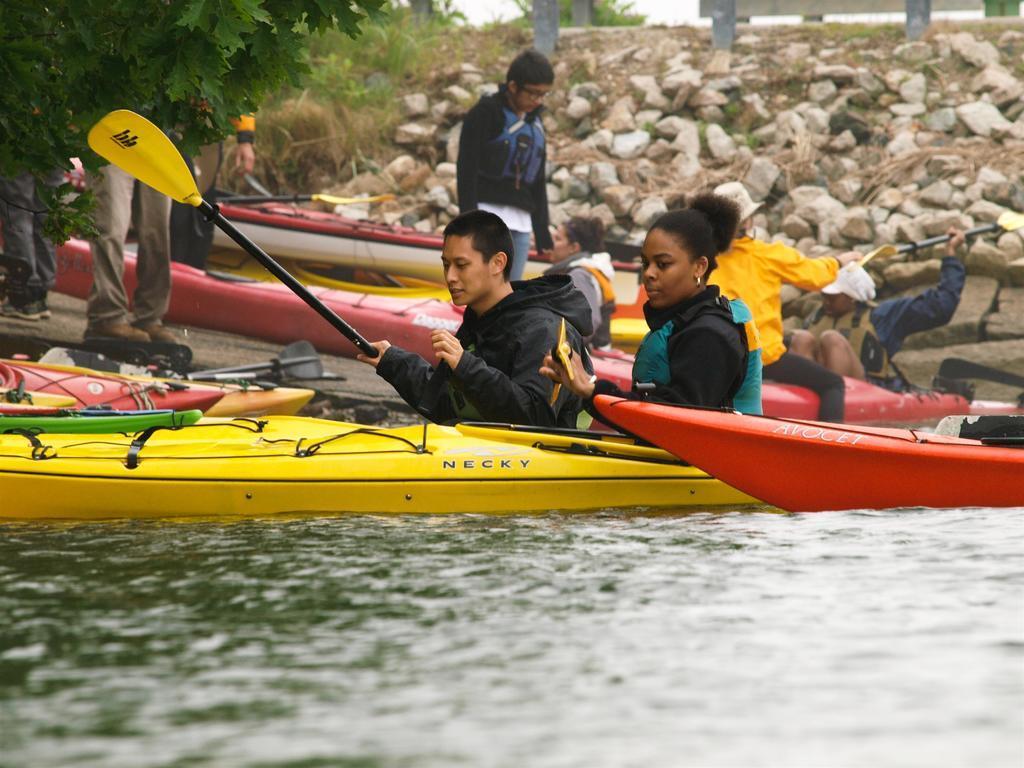Please provide a concise description of this image. In this image, we can see some people rowing boat and in the background, there are trees, rocks, and some boats. At the bottom, there is water. 